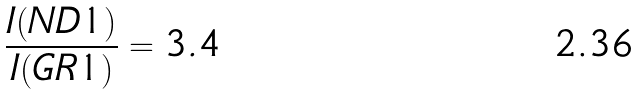Convert formula to latex. <formula><loc_0><loc_0><loc_500><loc_500>\frac { I ( N D 1 ) } { I ( G R 1 ) } = 3 . 4</formula> 